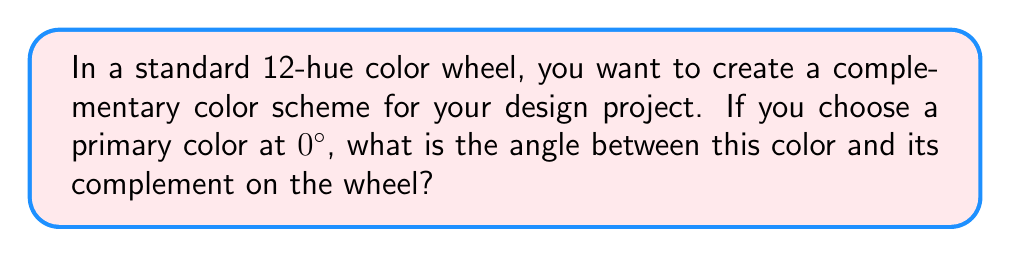Provide a solution to this math problem. To solve this problem, let's break it down into steps:

1) First, recall that a standard color wheel is divided into 360°, just like a circle.

2) In a 12-hue color wheel, each hue is evenly spaced. To calculate the angle between each hue:

   $$\text{Angle between hues} = \frac{360°}{12} = 30°$$

3) Complementary colors are directly opposite each other on the color wheel. This means they are separated by half of the total rotation of the wheel:

   $$\text{Angle to complement} = \frac{360°}{2} = 180°$$

4) We can verify this by counting the number of hue spaces between a color and its complement:

   $$\text{Number of spaces} = \frac{180°}{30°} = 6$$

   Indeed, in a 12-hue wheel, a color's complement is 6 spaces away.

5) Therefore, regardless of which primary color you choose at 0°, its complement will always be at an angle of 180° on the color wheel.

This 180° relationship between complementary colors creates a strong contrast that can be effectively used in design to create visual interest and balance.
Answer: The angle between a color and its complement on a 12-hue color wheel is $180°$. 